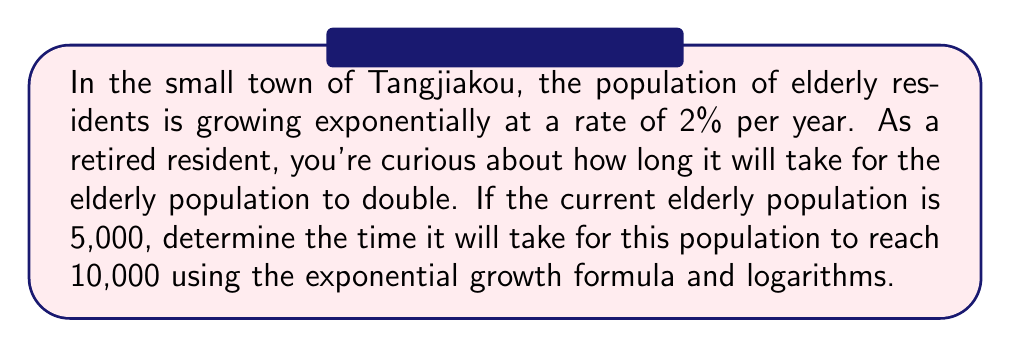Can you solve this math problem? Let's approach this step-by-step:

1) The exponential growth formula is:
   $$A = P(1 + r)^t$$
   Where:
   $A$ is the final amount
   $P$ is the initial amount
   $r$ is the growth rate (as a decimal)
   $t$ is the time

2) We know:
   $P = 5,000$
   $A = 10,000$ (double the initial population)
   $r = 0.02$ (2% expressed as a decimal)

3) Substituting these values:
   $$10,000 = 5,000(1 + 0.02)^t$$

4) Simplify:
   $$2 = (1.02)^t$$

5) To solve for $t$, we need to use logarithms. Taking the natural log of both sides:
   $$\ln(2) = \ln((1.02)^t)$$

6) Using the logarithm property $\ln(a^b) = b\ln(a)$:
   $$\ln(2) = t\ln(1.02)$$

7) Solve for $t$:
   $$t = \frac{\ln(2)}{\ln(1.02)}$$

8) Calculate:
   $$t \approx 35.00$$

Therefore, it will take approximately 35 years for the elderly population to double.
Answer: 35 years 